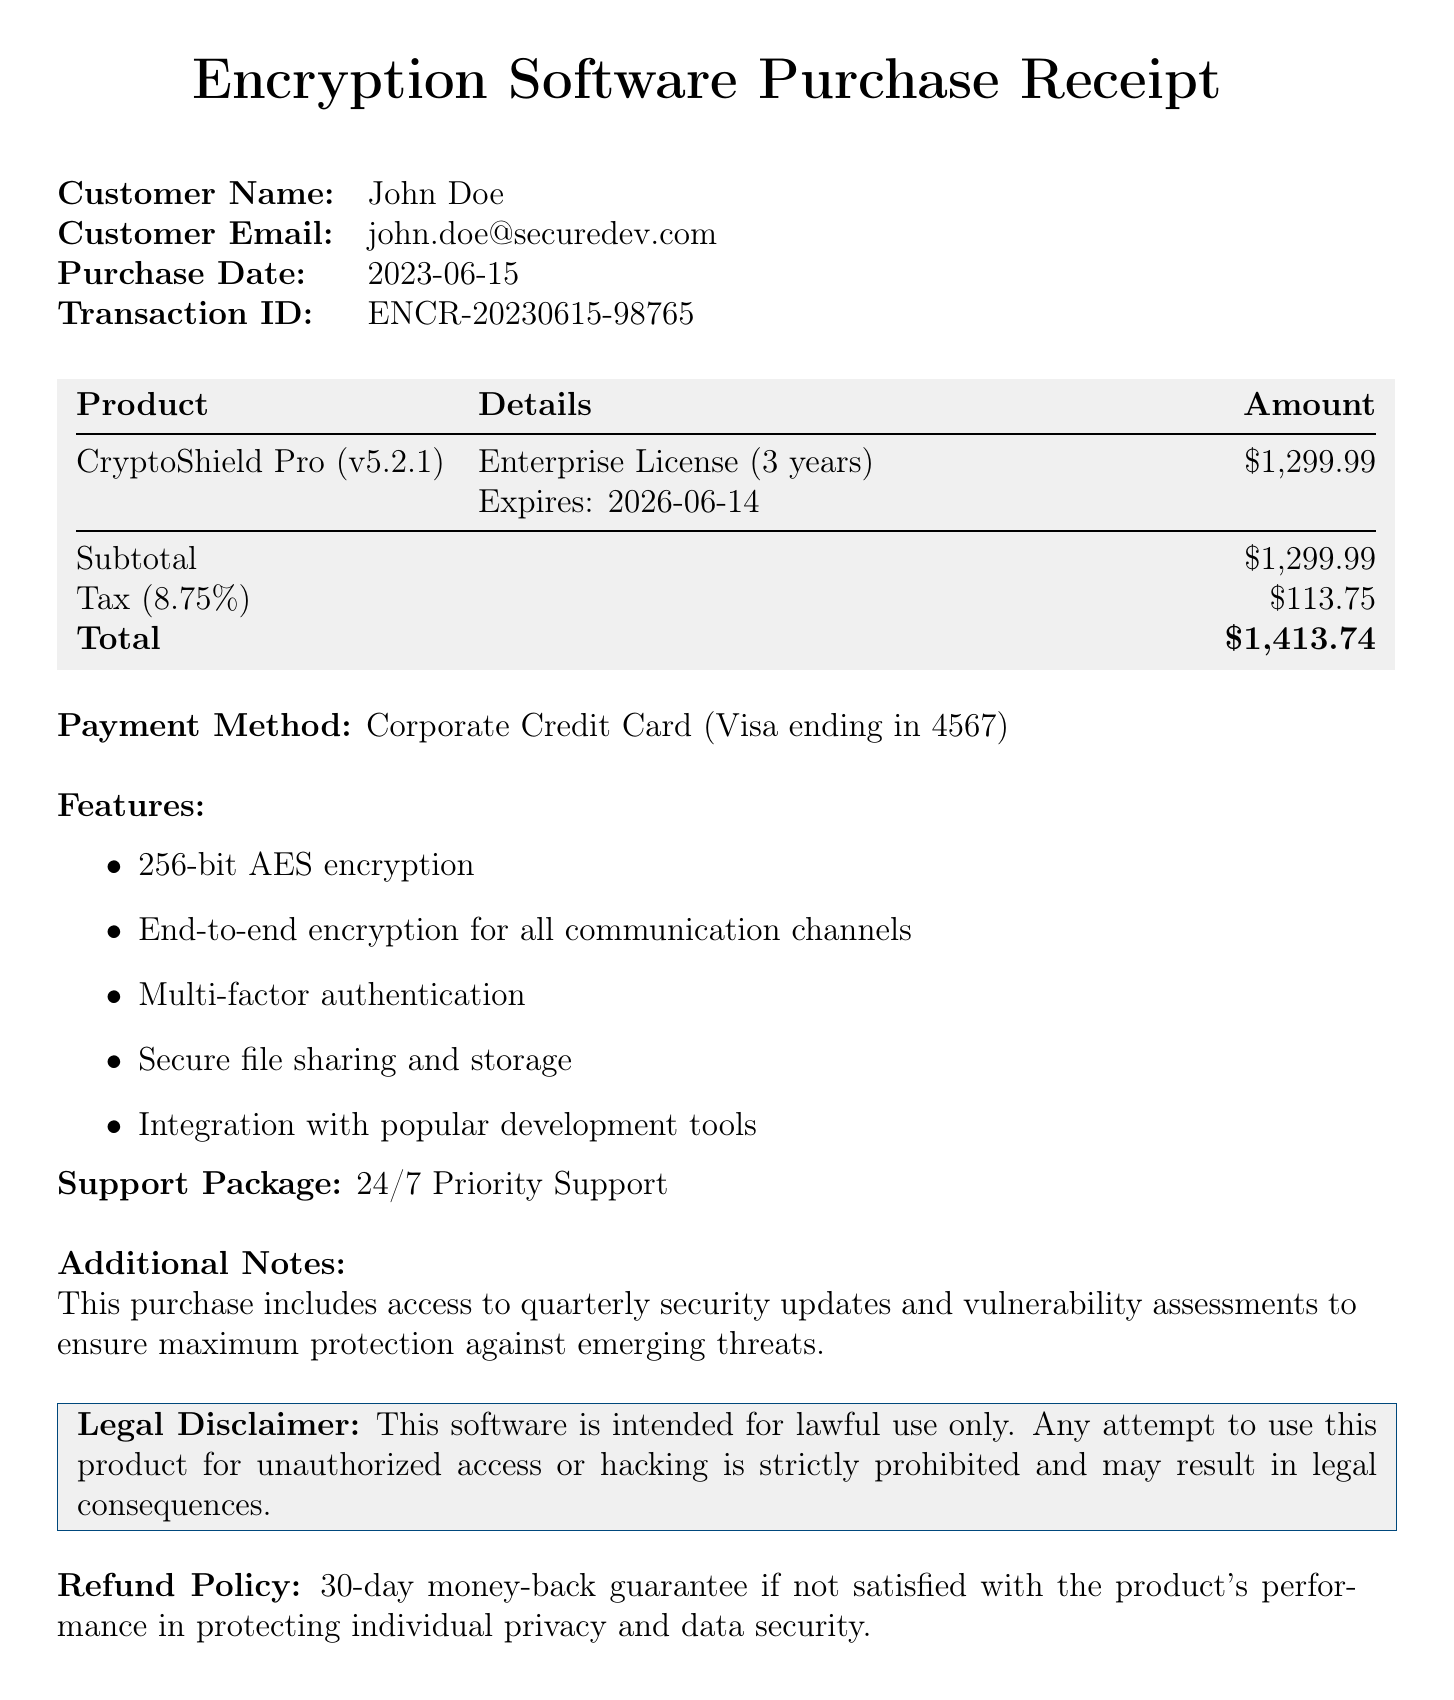What is the name of the company? The company name is listed at the top of the receipt.
Answer: SecureGuard Technologies, Inc What is the product version of CryptoShield Pro? The product version is provided in the product details section.
Answer: 5.2.1 What is the license type for the purchased software? The license type is mentioned in the details of the product.
Answer: Enterprise When does the license expire? The expiration date is clearly stated in the product license details.
Answer: 2026-06-14 What is the total amount paid? The total amount is shown in the financial summary of the receipt.
Answer: $1,413.74 What payment method was used for the transaction? The payment method is stated under the payment details section.
Answer: Corporate Credit Card (Visa ending in 4567) How long is the license duration? The license duration is specified alongside the license type in the product details.
Answer: 3 years What is included in the refund policy? The refund policy information is presented near the bottom of the receipt.
Answer: 30-day money-back guarantee What feature ensures communication safety? The features section lists capabilities of the software regarding communication.
Answer: End-to-end encryption for all communication channels What kind of support is offered with the software? The support package details are mentioned in the support section of the receipt.
Answer: 24/7 Priority Support 